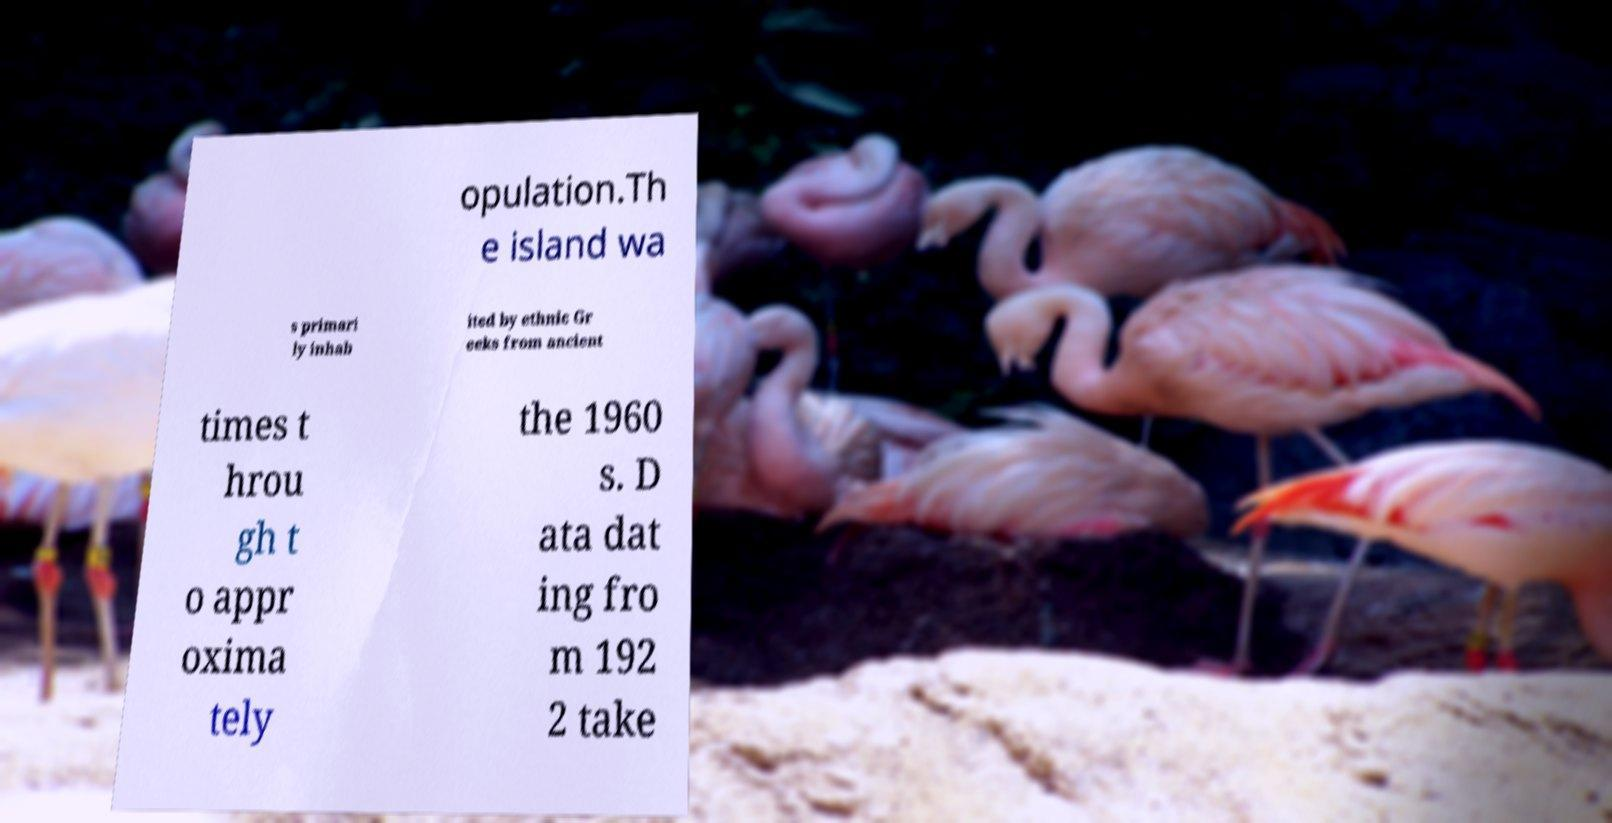What messages or text are displayed in this image? I need them in a readable, typed format. opulation.Th e island wa s primari ly inhab ited by ethnic Gr eeks from ancient times t hrou gh t o appr oxima tely the 1960 s. D ata dat ing fro m 192 2 take 